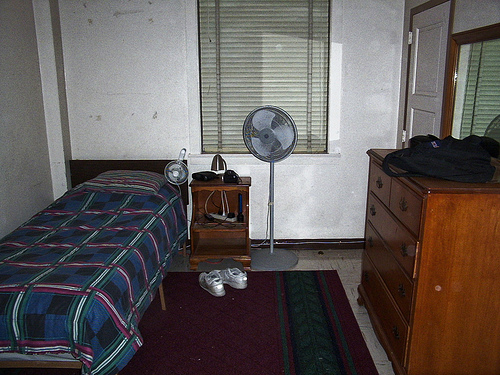<image>
Is there a fan behind the bed? Yes. From this viewpoint, the fan is positioned behind the bed, with the bed partially or fully occluding the fan. Is the fan in front of the sneakers? No. The fan is not in front of the sneakers. The spatial positioning shows a different relationship between these objects. 